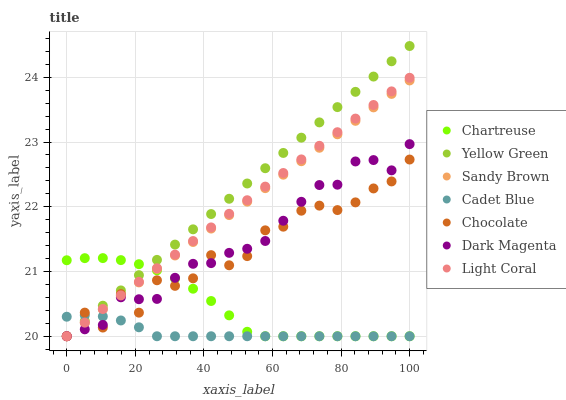Does Cadet Blue have the minimum area under the curve?
Answer yes or no. Yes. Does Yellow Green have the maximum area under the curve?
Answer yes or no. Yes. Does Chocolate have the minimum area under the curve?
Answer yes or no. No. Does Chocolate have the maximum area under the curve?
Answer yes or no. No. Is Yellow Green the smoothest?
Answer yes or no. Yes. Is Chocolate the roughest?
Answer yes or no. Yes. Is Chocolate the smoothest?
Answer yes or no. No. Is Yellow Green the roughest?
Answer yes or no. No. Does Cadet Blue have the lowest value?
Answer yes or no. Yes. Does Yellow Green have the highest value?
Answer yes or no. Yes. Does Chocolate have the highest value?
Answer yes or no. No. Does Light Coral intersect Cadet Blue?
Answer yes or no. Yes. Is Light Coral less than Cadet Blue?
Answer yes or no. No. Is Light Coral greater than Cadet Blue?
Answer yes or no. No. 